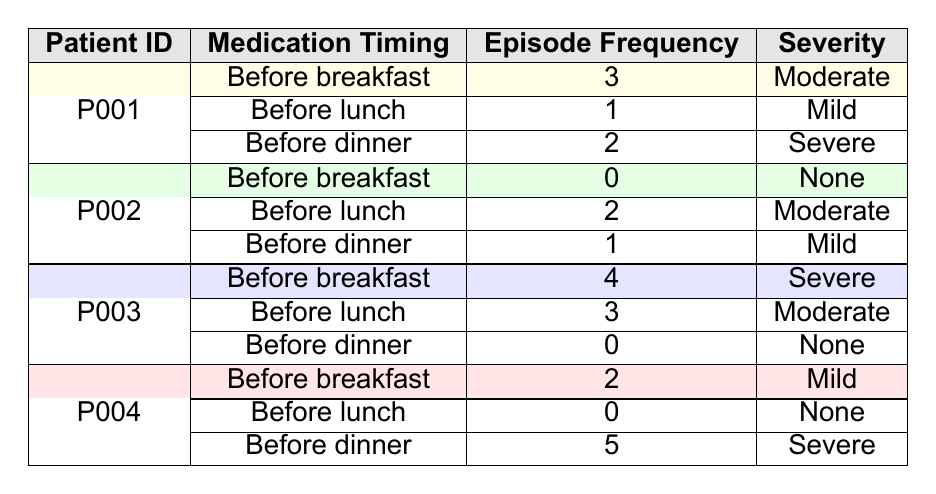What is the episode frequency for patient P001 before breakfast? The table shows that for patient P001, the medication timing is listed as "Before breakfast" with an episode frequency of 3.
Answer: 3 How many episodes did patient P002 experience before dinner? According to the table, patient P002 has a frequency of 1 episode listed for "Before dinner."
Answer: 1 Did patient P003 face any hypoglycemic episodes before dinner? The table indicates that patient P003's frequency for "Before dinner" is 0, meaning no episodes occurred.
Answer: Yes What is the total episode frequency for patient P004 across all medication timings? Patient P004's episodes are counted as follows: (2 for breakfast) + (0 for lunch) + (5 for dinner) = 7.
Answer: 7 Which patient had the highest frequency of episodes before breakfast? By comparing the data, patient P003 had the highest frequency of 4 episodes before breakfast.
Answer: P003 Is it true that all patients had at least one hypoglycemic episode before lunch? Reviewing the data, patient P002 had a count of 2 episodes and patient P001 had 1, but patient P004 had 0. Therefore, it is false.
Answer: No What is the average episode frequency for patient P001? To compute the average, add the episodes: (3 + 1 + 2) = 6 episodes over 3 timings, which gives an average of 6/3 = 2.
Answer: 2 For which medication timing did patient P004 have the most severe episodes? The data reveals that patient P004 had the highest severity rating of "Severe" for "Before dinner," with an episode frequency of 5.
Answer: Before dinner What is the total number of mild hypoglycemic episodes across all patients? The table indicates mild episodes are shown for patient P001 (1), patient P002 (1), patient P004 (2). Adding these values yields a total of 1 + 1 + 2 = 4 mild episodes.
Answer: 4 